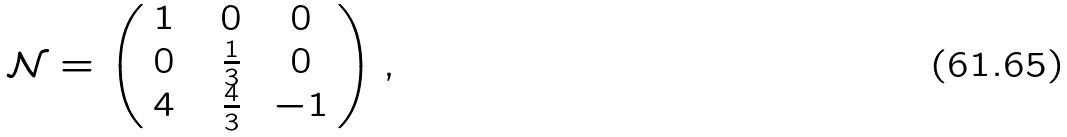Convert formula to latex. <formula><loc_0><loc_0><loc_500><loc_500>\mathcal { N } = \left ( \begin{array} { c c c } 1 \ & \ 0 \ & \ 0 \ \\ 0 \ & \ \frac { 1 } { 3 } \ & \ 0 \ \\ 4 \ & \ \frac { 4 } { 3 } \ & - 1 \end{array} \right ) ,</formula> 